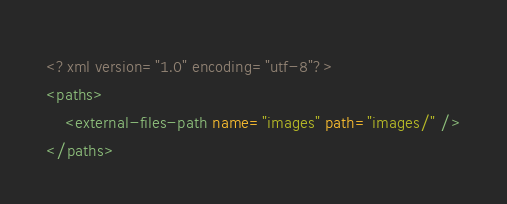<code> <loc_0><loc_0><loc_500><loc_500><_XML_><?xml version="1.0" encoding="utf-8"?>
<paths>
    <external-files-path name="images" path="images/" />
</paths></code> 